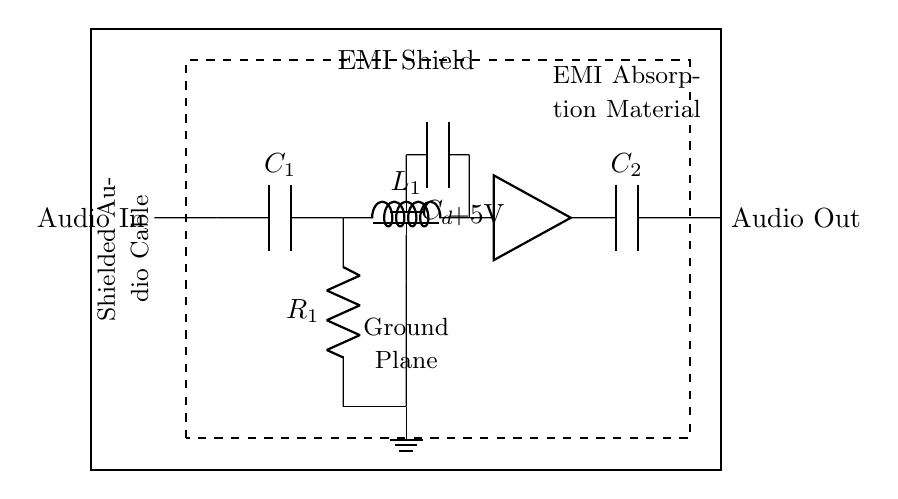What is the input component type in the circuit? The input component type is a capacitor labeled C1, which is positioned at the start of the signal path in the input filter section.
Answer: Capacitor What is the output component following the amplifier? The output component following the amplifier is a capacitor labeled C2, which functions as a filter to ensure the output audio signal is free of unwanted frequencies.
Answer: Capacitor How many decoupling capacitors are present in the circuit? There is one decoupling capacitor labeled Cd, which connects the power supply to the amplifier to stabilize the voltage and filter out noise.
Answer: One Why is there an EMI shield represented in the diagram? The EMI shield is essential for protecting sensitive audio devices from electromagnetic interference, which could distort the audio signal. This protection is achieved through the shield's enclosing design.
Answer: Protection from EMI What is the voltage supplied by the battery? The voltage supplied by the battery is indicated as +5V, which is the potential delivered to the circuit to power the components.
Answer: 5V Which component is responsible for filtering the audio signal at the input? The inductor labeled L1 is responsible for filtering the audio signal at the input, as it helps to block high-frequency noise while allowing lower-frequency audio signals to pass through.
Answer: Inductor What does the dashed rectangle surrounding the circuit represent? The dashed rectangle represents the EMI absorption material, which enhances the circuit's ability to shield against electromagnetic interference.
Answer: EMI Absorption Material 